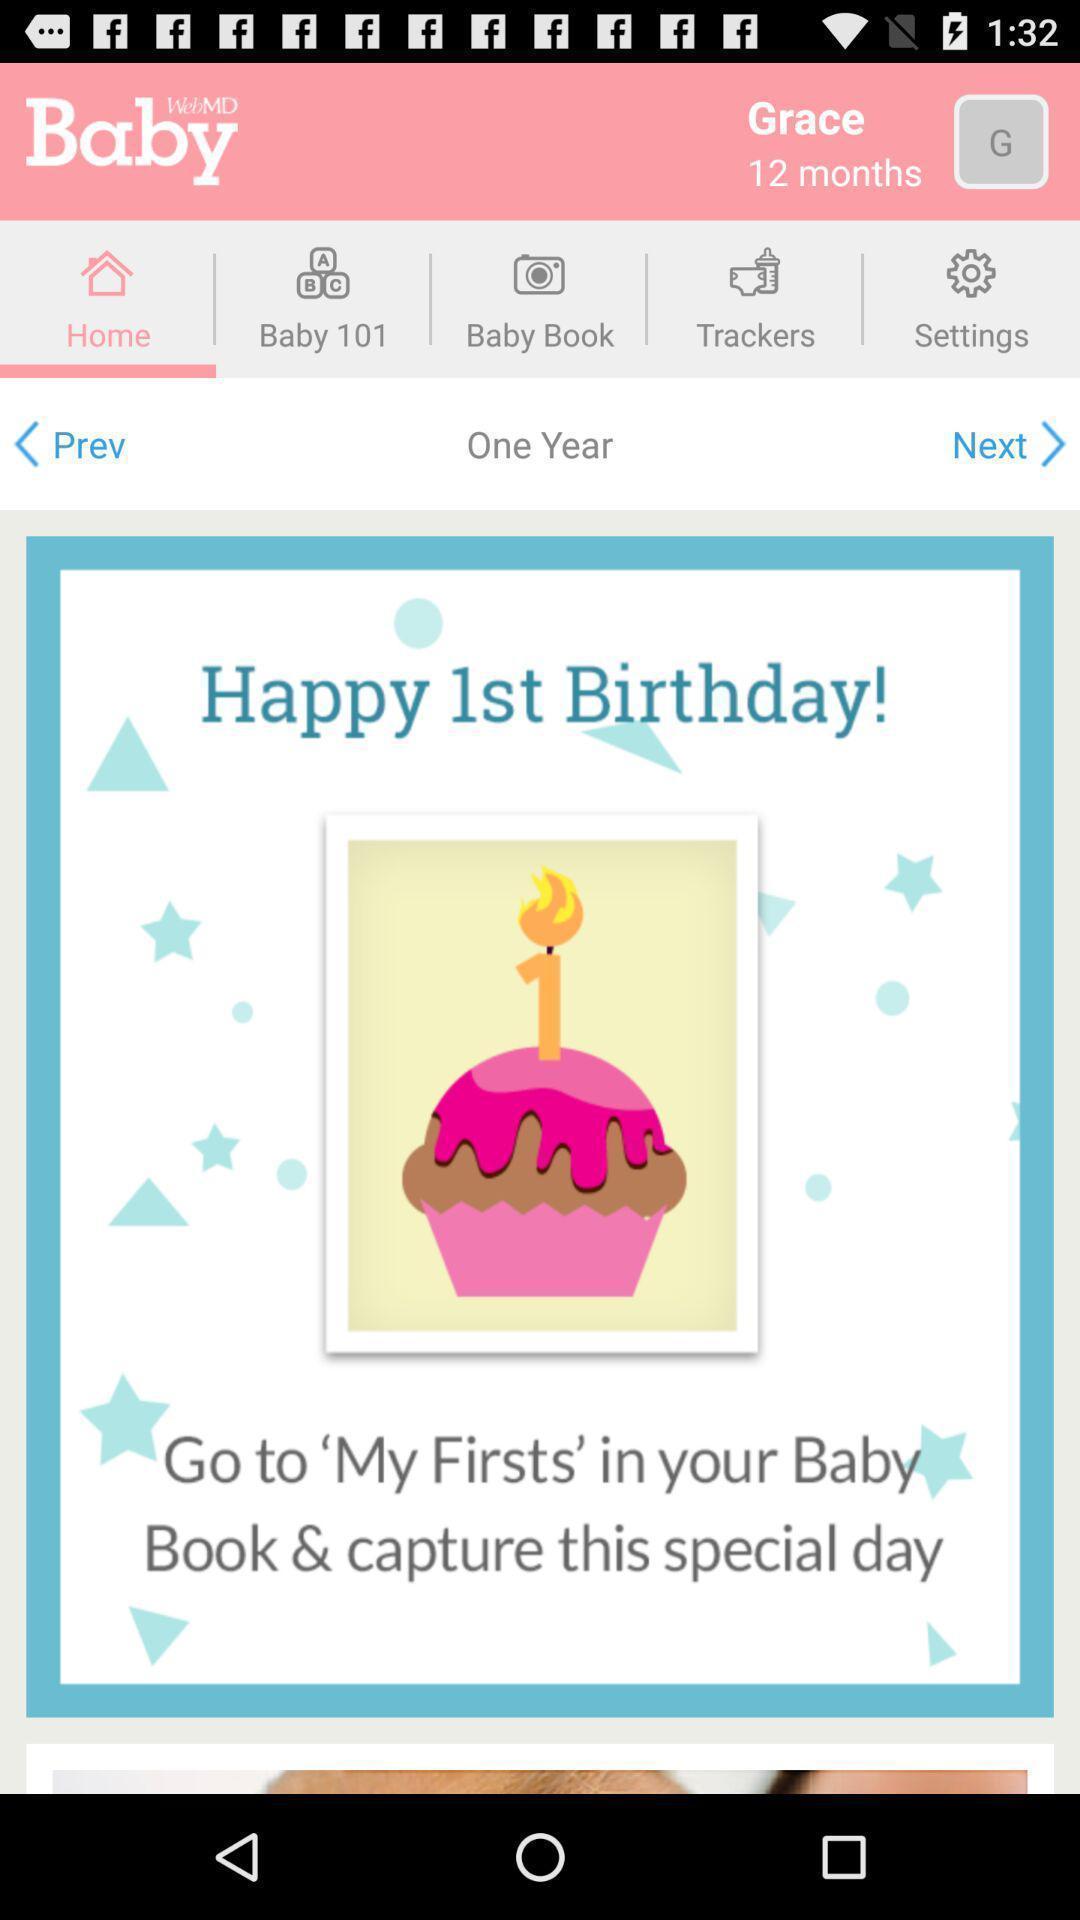Summarize the information in this screenshot. Page showing information about baby 's development. 